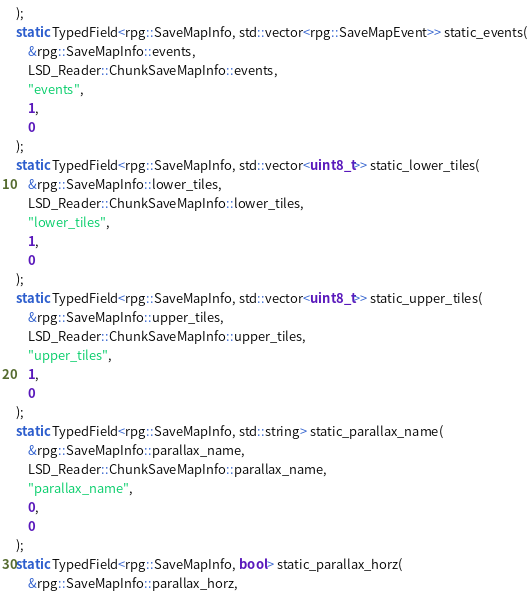<code> <loc_0><loc_0><loc_500><loc_500><_C++_>);
static TypedField<rpg::SaveMapInfo, std::vector<rpg::SaveMapEvent>> static_events(
	&rpg::SaveMapInfo::events,
	LSD_Reader::ChunkSaveMapInfo::events,
	"events",
	1,
	0
);
static TypedField<rpg::SaveMapInfo, std::vector<uint8_t>> static_lower_tiles(
	&rpg::SaveMapInfo::lower_tiles,
	LSD_Reader::ChunkSaveMapInfo::lower_tiles,
	"lower_tiles",
	1,
	0
);
static TypedField<rpg::SaveMapInfo, std::vector<uint8_t>> static_upper_tiles(
	&rpg::SaveMapInfo::upper_tiles,
	LSD_Reader::ChunkSaveMapInfo::upper_tiles,
	"upper_tiles",
	1,
	0
);
static TypedField<rpg::SaveMapInfo, std::string> static_parallax_name(
	&rpg::SaveMapInfo::parallax_name,
	LSD_Reader::ChunkSaveMapInfo::parallax_name,
	"parallax_name",
	0,
	0
);
static TypedField<rpg::SaveMapInfo, bool> static_parallax_horz(
	&rpg::SaveMapInfo::parallax_horz,</code> 